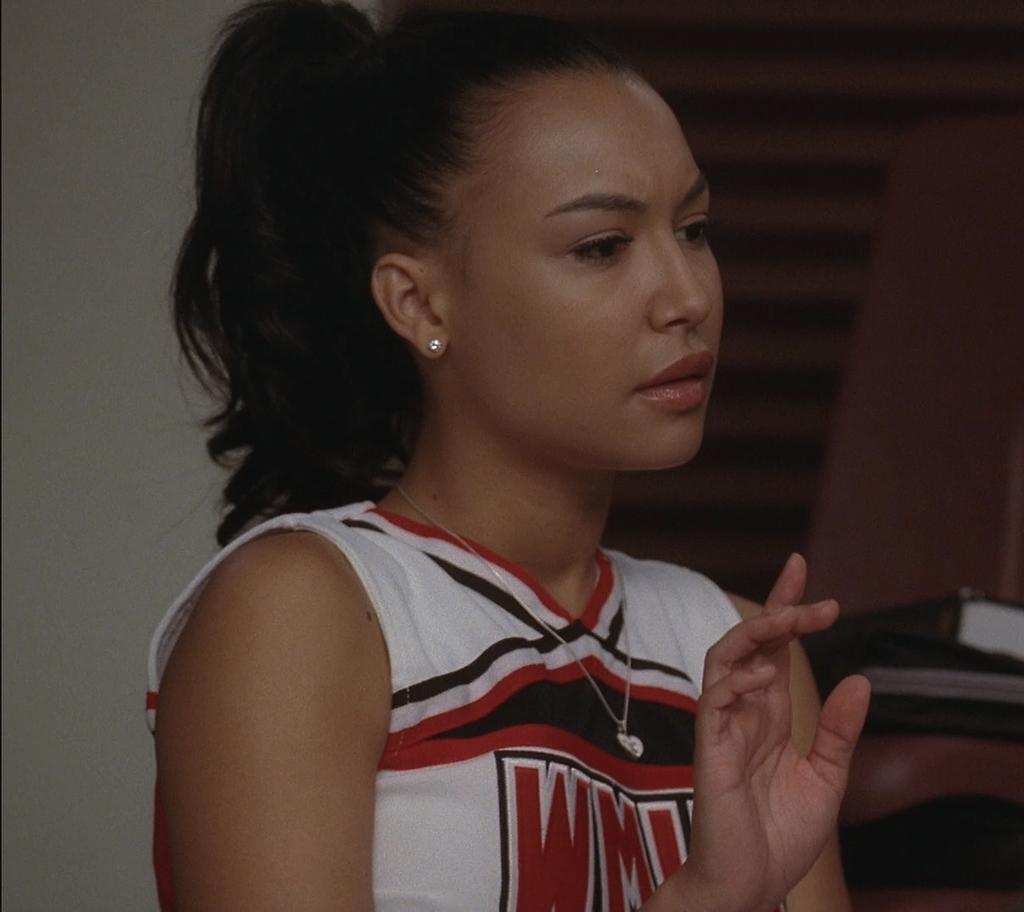<image>
Relay a brief, clear account of the picture shown. W is the first letter of the word written on this cheer leader's top. 